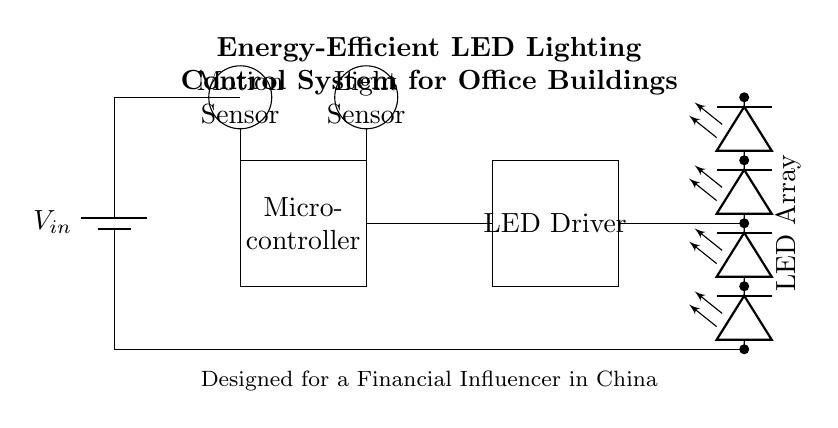What is the input voltage of this system? The input voltage is represented by the symbol \( V_{in} \) next to the battery in the circuit diagram, indicating the source of power for the system.
Answer: \( V_{in} \) What is the function of the microcontroller in this circuit? The microcontroller is responsible for processing information from the sensors (motion and light) to control the LED driver based on environmental conditions and user requirements.
Answer: Control How many LEDs are in the LED array? The LED array consists of four individual LEDs stacked vertically, as indicated by the sequence of symbols connected together in the diagram.
Answer: Four What component connects to both the light sensor and LED driver? The microcontroller connects to both the light sensor (to receive light intensity data) and the LED driver (to control the operation of the LEDs based on input).
Answer: Microcontroller How does the motion sensor affect the LED array? When the motion sensor detects movement, it sends a signal to the microcontroller, which may enable the LED driver to turn on the LED array, enhancing visibility in the area.
Answer: Enables lighting What type of sensors are used in this lighting control system? The system uses a motion sensor to detect presence and a light sensor to gauge ambient light levels, optimizing energy usage and lighting conditions.
Answer: Motion and light sensors What is the purpose of the energy-efficient design in this lighting system? The purpose is to provide sustainable and cost-effective lighting solutions that reduce energy consumption while maintaining adequate illumination levels in office buildings.
Answer: Energy-saving 